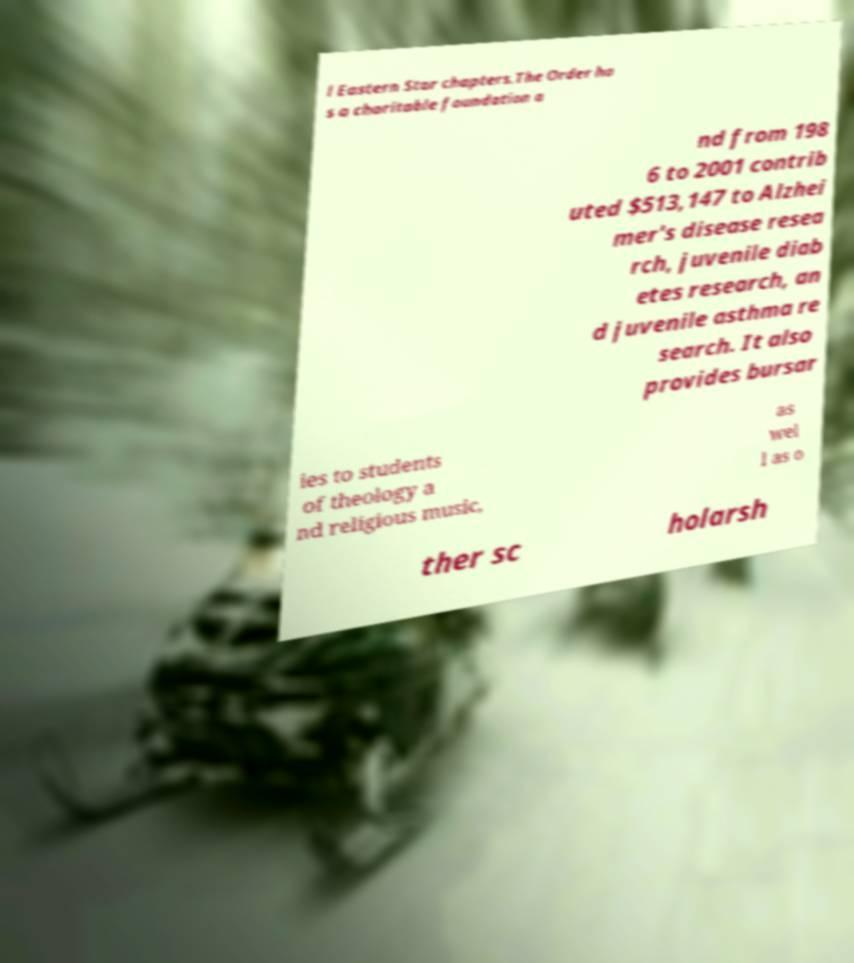There's text embedded in this image that I need extracted. Can you transcribe it verbatim? l Eastern Star chapters.The Order ha s a charitable foundation a nd from 198 6 to 2001 contrib uted $513,147 to Alzhei mer's disease resea rch, juvenile diab etes research, an d juvenile asthma re search. It also provides bursar ies to students of theology a nd religious music, as wel l as o ther sc holarsh 